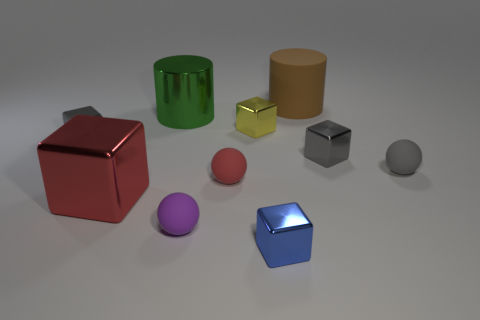Subtract 2 cubes. How many cubes are left? 3 Subtract all blue balls. Subtract all gray cylinders. How many balls are left? 3 Subtract all cylinders. How many objects are left? 8 Add 4 small blue things. How many small blue things are left? 5 Add 5 tiny red spheres. How many tiny red spheres exist? 6 Subtract 0 red cylinders. How many objects are left? 10 Subtract all large cyan matte things. Subtract all blue metal things. How many objects are left? 9 